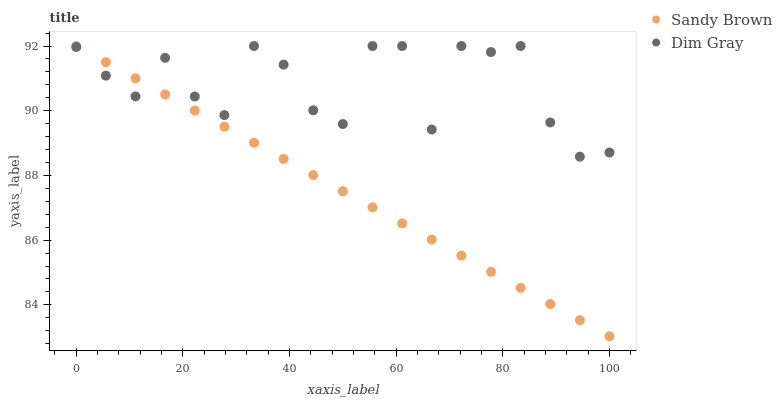Does Sandy Brown have the minimum area under the curve?
Answer yes or no. Yes. Does Dim Gray have the maximum area under the curve?
Answer yes or no. Yes. Does Sandy Brown have the maximum area under the curve?
Answer yes or no. No. Is Sandy Brown the smoothest?
Answer yes or no. Yes. Is Dim Gray the roughest?
Answer yes or no. Yes. Is Sandy Brown the roughest?
Answer yes or no. No. Does Sandy Brown have the lowest value?
Answer yes or no. Yes. Does Sandy Brown have the highest value?
Answer yes or no. Yes. Does Dim Gray intersect Sandy Brown?
Answer yes or no. Yes. Is Dim Gray less than Sandy Brown?
Answer yes or no. No. Is Dim Gray greater than Sandy Brown?
Answer yes or no. No. 